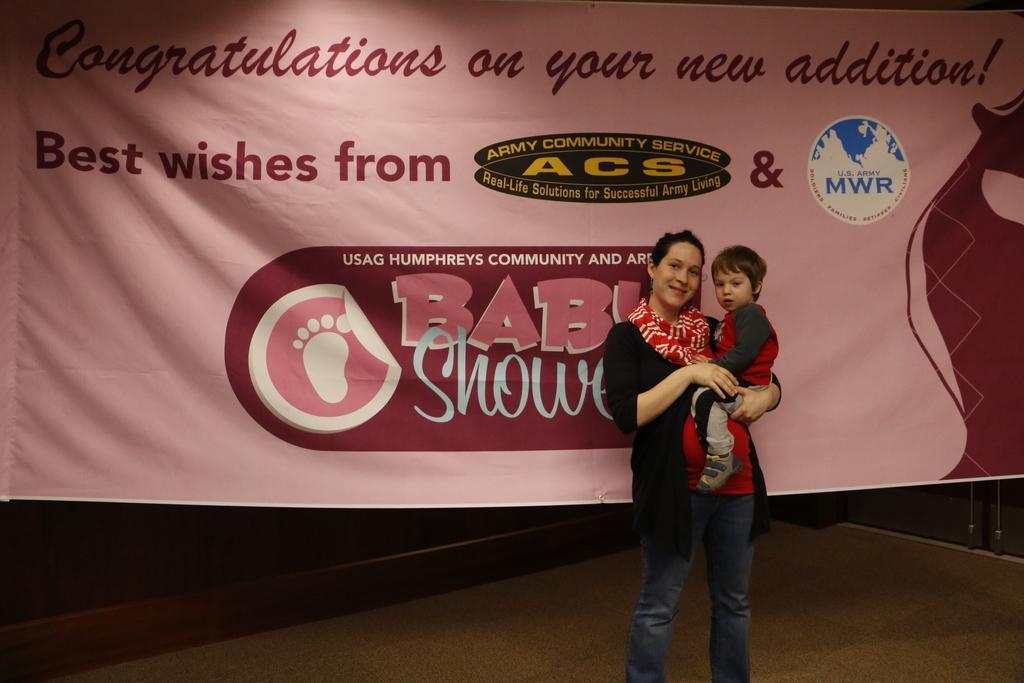Describe this image in one or two sentences. This image consists of a woman wearing a black jacket and holding a kid. In the background, there is a banner. At the bottom, there is a floor. On the right, we can see a door. 